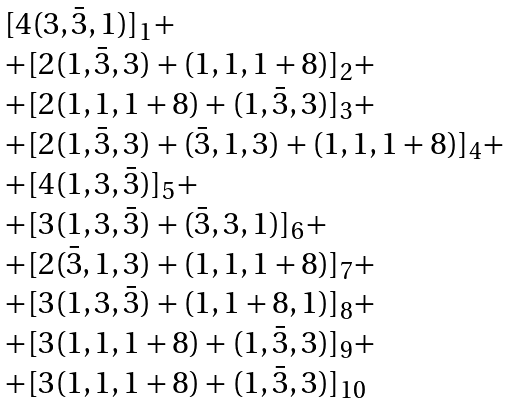<formula> <loc_0><loc_0><loc_500><loc_500>\begin{array} { l } { { [ 4 ( 3 , \bar { 3 } , 1 ) ] _ { 1 } + } } \\ { { + [ 2 ( 1 , \bar { 3 } , 3 ) + ( 1 , 1 , 1 + 8 ) ] _ { 2 } + } } \\ { { + [ 2 ( 1 , 1 , 1 + 8 ) + ( 1 , \bar { 3 } , 3 ) ] _ { 3 } + } } \\ { { + [ 2 ( 1 , \bar { 3 } , 3 ) + ( \bar { 3 } , 1 , 3 ) + ( 1 , 1 , 1 + 8 ) ] _ { 4 } + } } \\ { { + [ 4 ( 1 , 3 , \bar { 3 } ) ] _ { 5 } + } } \\ { { + [ 3 ( 1 , 3 , \bar { 3 } ) + ( \bar { 3 } , 3 , 1 ) ] _ { 6 } + } } \\ { { + [ 2 ( \bar { 3 } , 1 , 3 ) + ( 1 , 1 , 1 + 8 ) ] _ { 7 } + } } \\ { { + [ 3 ( 1 , 3 , \bar { 3 } ) + ( 1 , 1 + 8 , 1 ) ] _ { 8 } + } } \\ { { + [ 3 ( 1 , 1 , 1 + 8 ) + ( 1 , \bar { 3 } , 3 ) ] _ { 9 } + } } \\ { { + [ 3 ( 1 , 1 , 1 + 8 ) + ( 1 , \bar { 3 } , 3 ) ] _ { 1 0 } } } \end{array}</formula> 